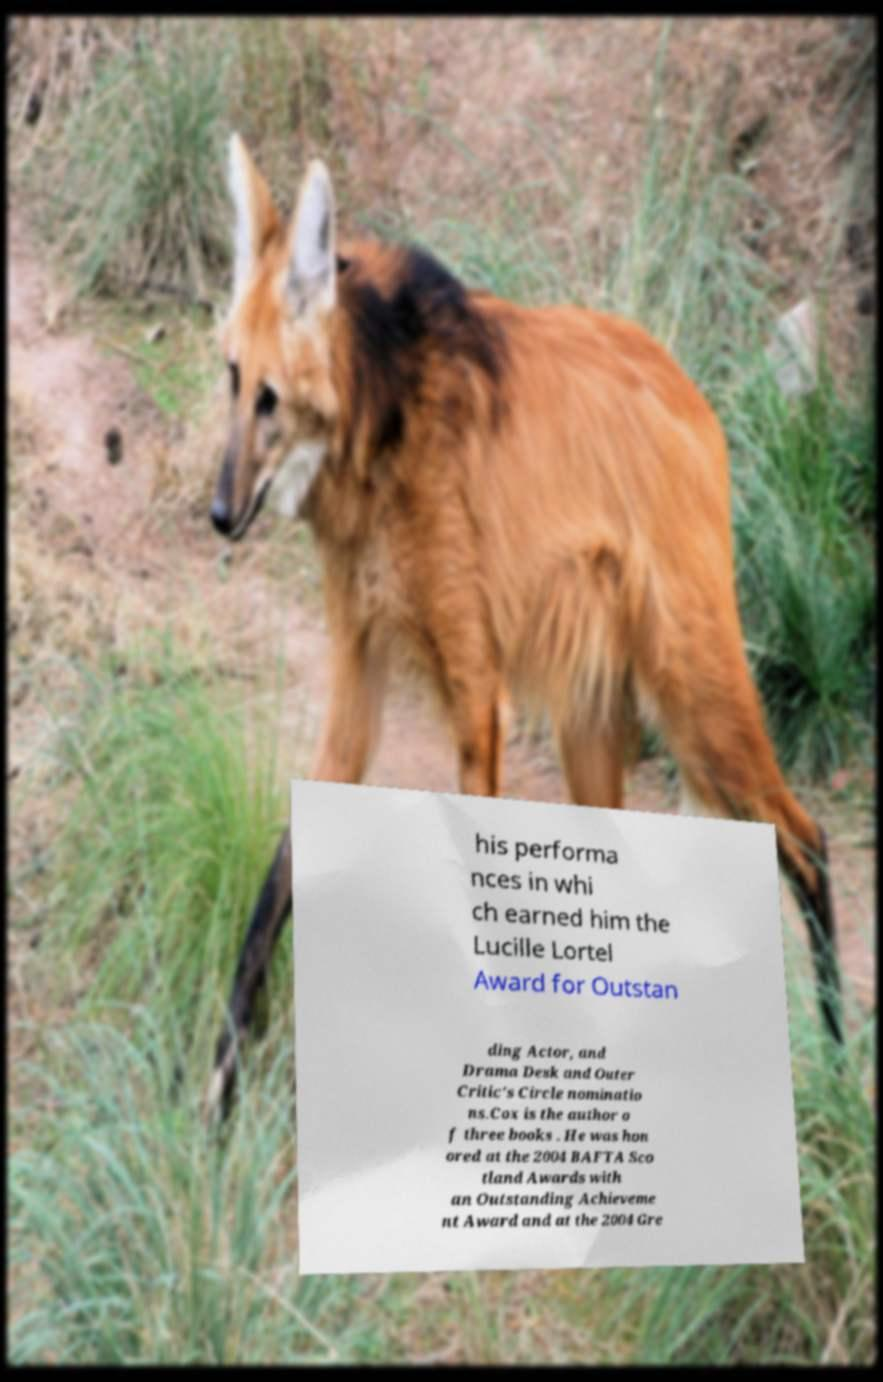What messages or text are displayed in this image? I need them in a readable, typed format. his performa nces in whi ch earned him the Lucille Lortel Award for Outstan ding Actor, and Drama Desk and Outer Critic's Circle nominatio ns.Cox is the author o f three books . He was hon ored at the 2004 BAFTA Sco tland Awards with an Outstanding Achieveme nt Award and at the 2004 Gre 